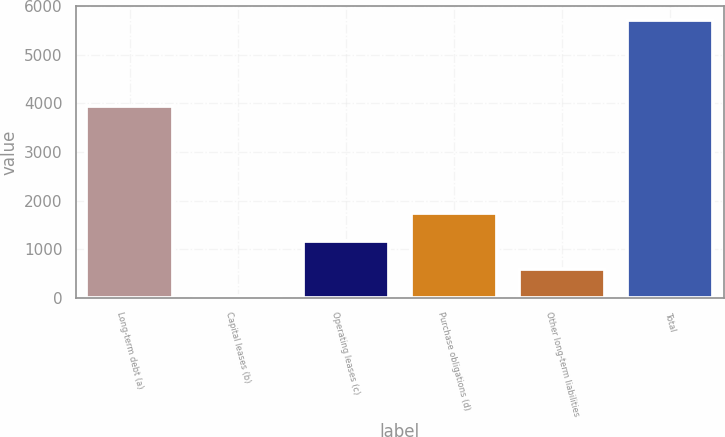Convert chart. <chart><loc_0><loc_0><loc_500><loc_500><bar_chart><fcel>Long-term debt (a)<fcel>Capital leases (b)<fcel>Operating leases (c)<fcel>Purchase obligations (d)<fcel>Other long-term liabilities<fcel>Total<nl><fcel>3939<fcel>35<fcel>1171<fcel>1739<fcel>603<fcel>5715<nl></chart> 